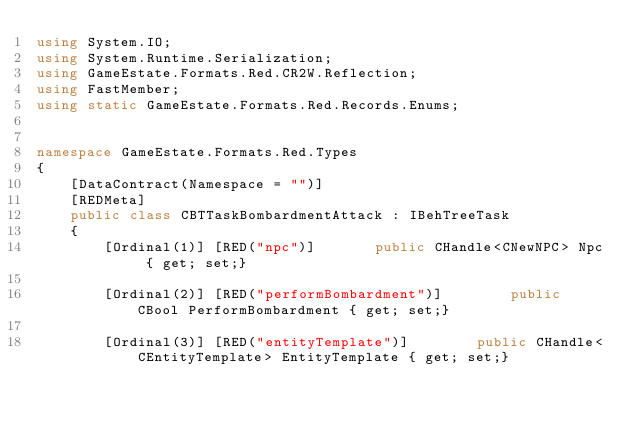Convert code to text. <code><loc_0><loc_0><loc_500><loc_500><_C#_>using System.IO;
using System.Runtime.Serialization;
using GameEstate.Formats.Red.CR2W.Reflection;
using FastMember;
using static GameEstate.Formats.Red.Records.Enums;


namespace GameEstate.Formats.Red.Types
{
	[DataContract(Namespace = "")]
	[REDMeta]
	public class CBTTaskBombardmentAttack : IBehTreeTask
	{
		[Ordinal(1)] [RED("npc")] 		public CHandle<CNewNPC> Npc { get; set;}

		[Ordinal(2)] [RED("performBombardment")] 		public CBool PerformBombardment { get; set;}

		[Ordinal(3)] [RED("entityTemplate")] 		public CHandle<CEntityTemplate> EntityTemplate { get; set;}
</code> 